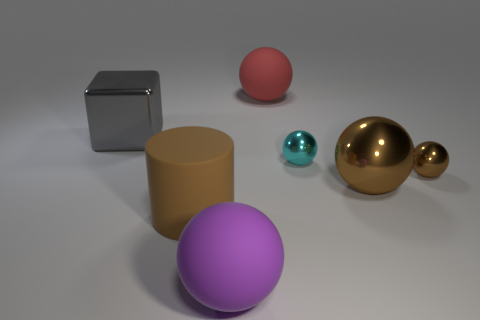Is the cylinder the same color as the big metal ball?
Provide a succinct answer. Yes. The small thing that is the same color as the big rubber cylinder is what shape?
Offer a terse response. Sphere. Is there a purple thing that has the same material as the small brown ball?
Offer a very short reply. No. Do the big red ball and the small object behind the small brown ball have the same material?
Your answer should be very brief. No. What is the color of the object that is the same size as the cyan shiny sphere?
Provide a succinct answer. Brown. There is a cyan metallic ball that is to the right of the matte sphere in front of the cyan sphere; what is its size?
Make the answer very short. Small. There is a large cylinder; is its color the same as the big metallic object to the right of the brown matte object?
Ensure brevity in your answer.  Yes. Are there fewer brown matte cylinders to the right of the purple matte ball than tiny yellow spheres?
Provide a succinct answer. No. How many other objects are the same size as the brown cylinder?
Your answer should be very brief. 4. There is a big shiny object right of the metallic block; does it have the same shape as the red thing?
Offer a terse response. Yes. 